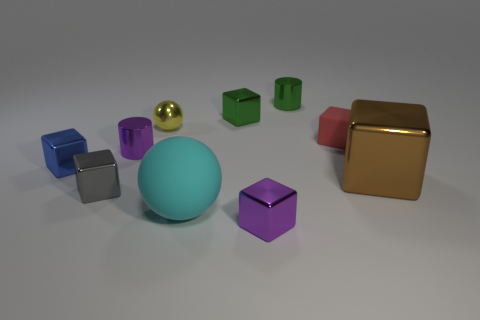Are there any small green metal cylinders that are right of the matte thing behind the purple shiny object that is behind the large matte ball?
Keep it short and to the point. No. What shape is the matte thing that is the same size as the yellow metallic ball?
Provide a short and direct response. Cube. There is a ball that is on the right side of the small shiny sphere; is its size the same as the cylinder in front of the small red block?
Ensure brevity in your answer.  No. How many brown metallic blocks are there?
Provide a succinct answer. 1. What is the size of the purple shiny thing on the right side of the shiny sphere that is in front of the shiny cylinder behind the yellow sphere?
Keep it short and to the point. Small. Does the big rubber ball have the same color as the large metal thing?
Keep it short and to the point. No. Are there any other things that are the same size as the cyan rubber object?
Offer a terse response. Yes. What number of red matte blocks are on the right side of the cyan matte object?
Provide a succinct answer. 1. Is the number of rubber blocks that are in front of the purple cylinder the same as the number of big brown metal objects?
Provide a succinct answer. No. What number of objects are small red blocks or tiny blue metal objects?
Keep it short and to the point. 2. 